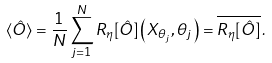<formula> <loc_0><loc_0><loc_500><loc_500>\langle \hat { O } \rangle = \frac { 1 } { N } \sum _ { j = 1 } ^ { N } R _ { \eta } [ \hat { O } ] \left ( X _ { \theta _ { j } } , \theta _ { j } \right ) = \overline { R _ { \eta } [ \hat { O } ] } \, .</formula> 